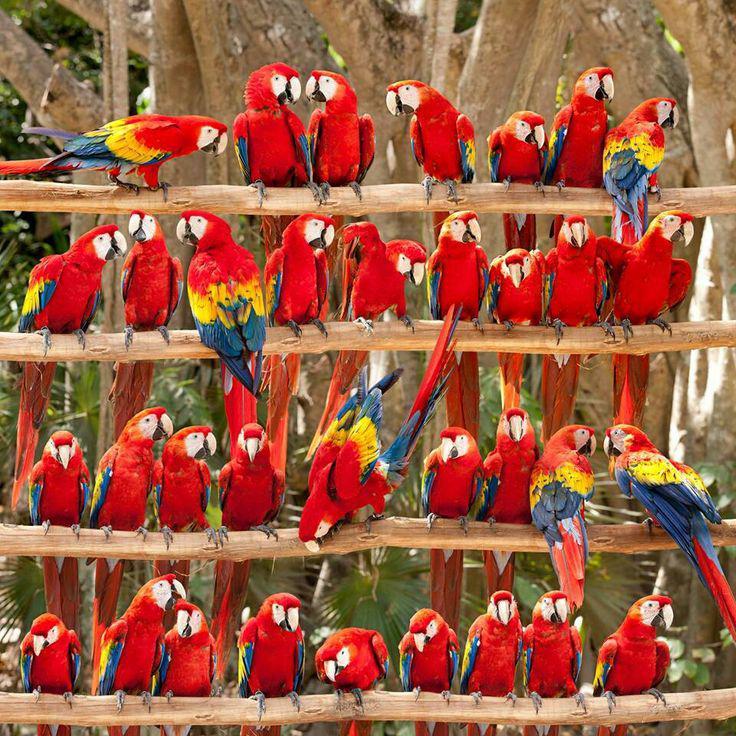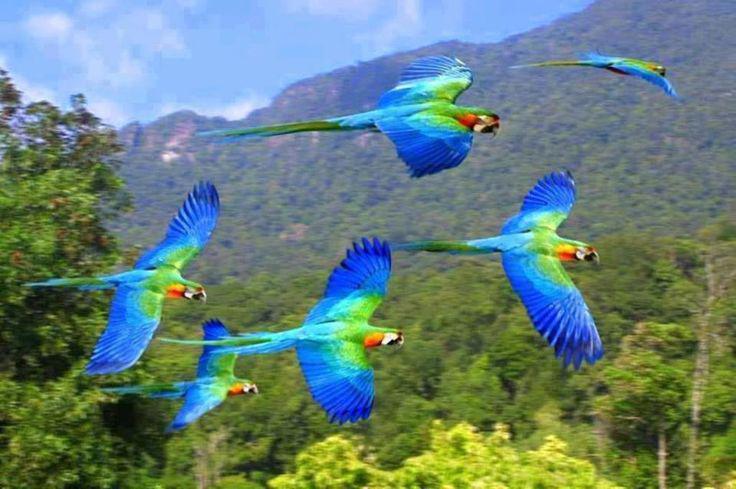The first image is the image on the left, the second image is the image on the right. Examine the images to the left and right. Is the description "The birds on the right are blue, green and orange." accurate? Answer yes or no. Yes. 